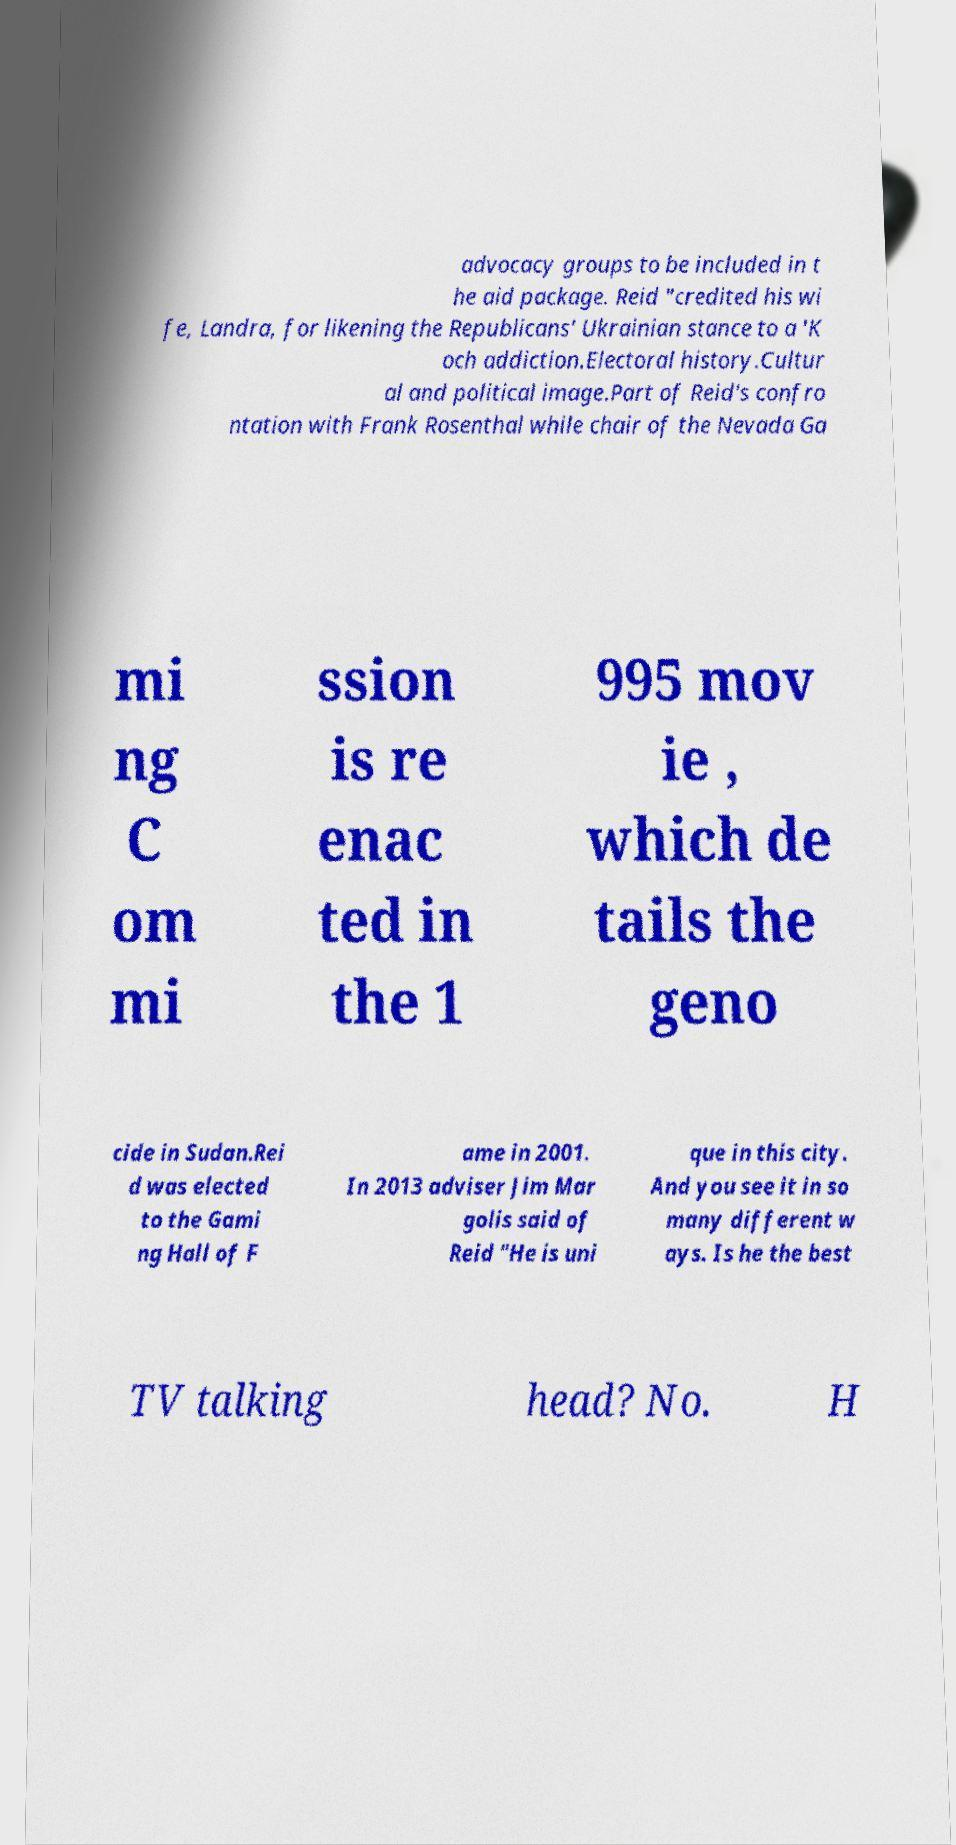Can you accurately transcribe the text from the provided image for me? advocacy groups to be included in t he aid package. Reid "credited his wi fe, Landra, for likening the Republicans' Ukrainian stance to a 'K och addiction.Electoral history.Cultur al and political image.Part of Reid's confro ntation with Frank Rosenthal while chair of the Nevada Ga mi ng C om mi ssion is re enac ted in the 1 995 mov ie , which de tails the geno cide in Sudan.Rei d was elected to the Gami ng Hall of F ame in 2001. In 2013 adviser Jim Mar golis said of Reid "He is uni que in this city. And you see it in so many different w ays. Is he the best TV talking head? No. H 